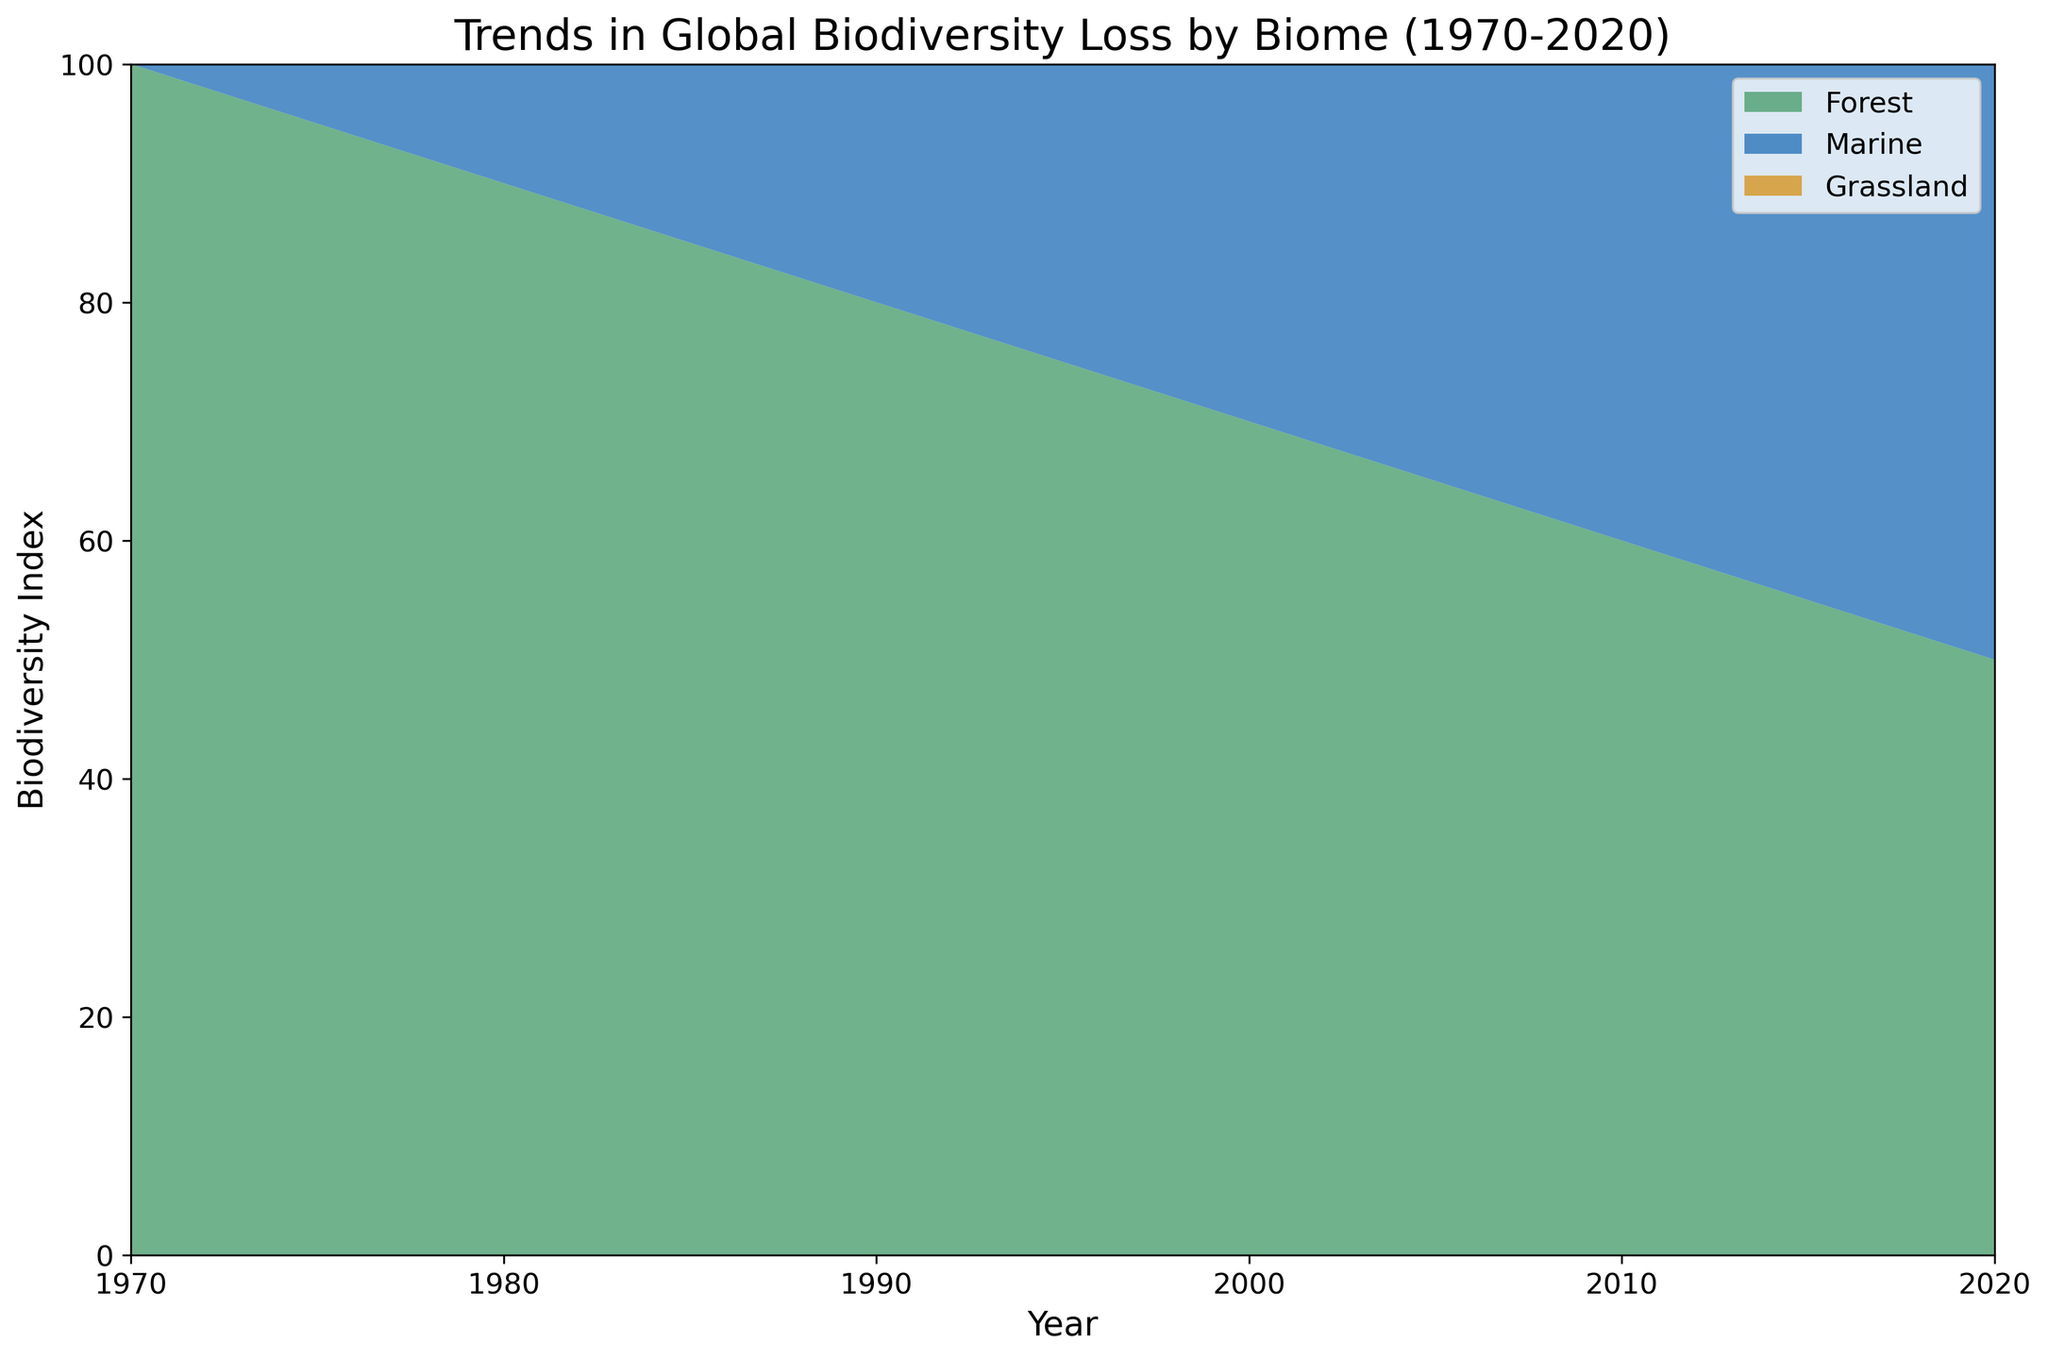What is the biodiversity index for forest in 1990? Find the value on the area chart that corresponds to the year 1990 in the forest section (green area). The value is 80.
Answer: 80 Between 1980 and 2000, which biome shows the greatest decrease in biodiversity index? Compare the decrease in biodiversity index for each biome from 1980 to 2000. The forest shows a decrease from 90 to 70 (20 units), the marine from 94 to 80 (14 units), and the grassland from 96 to 84 (12 units). The greatest decrease is seen in the forest biome.
Answer: Forest What is the average biodiversity index for the marine biome from 1970 to 2020? Sum the values of the marine biome biodiversity index and divide by the number of years: (100 + 97 + 94 + 91 + 88 + 84 + 80 + 76 + 72 + 68 + 65) / 11 = 84.
Answer: 84 In which year do the forest and grassland biomes show an equal biodiversity index? Observe the area chart to identify the year where the height of the green (forest) and brown (grassland) sections match. This happens in the year 2020, where both indices are at 65.
Answer: 2020 What's the difference in biodiversity index between the marine and grassland biomes in 1995? Locate the values for both marine and grassland biomes in the year 1995. Marine is 84, and grassland is 88. The difference is 88 - 84 = 4.
Answer: 4 Which biome had the slowest rate of biodiversity loss from 1970 to 2020? Calculate the rate of loss for each biome over the period: Forest lost 50 units, Marine lost 35 units, Grassland lost 35 units. The marine and grassland biomes both had the slowest rate, with a reduction of 35 units.
Answer: Marine and Grassland Describe the overall trend in biodiversity index for the forest biome. The forest biome shows a continuous decrease in biodiversity index from 100 in 1970 to 50 in 2020.
Answer: Continuous decrease How does the biodiversity index of marine biomes in 2000 compare to that in 1985? The marine biodiversity index in 1985 is 91, and in 2000 it is 80. The index decreased by 11 units over this period (91 - 80 = 11).
Answer: It decreased by 11 units Is there any year where the biodiversity index of grassland is higher than that of the forest? By examining the chart, in every year, the biodiversity index of grassland is either lower or equal to that of the forest. Therefore, the answer is no.
Answer: No 